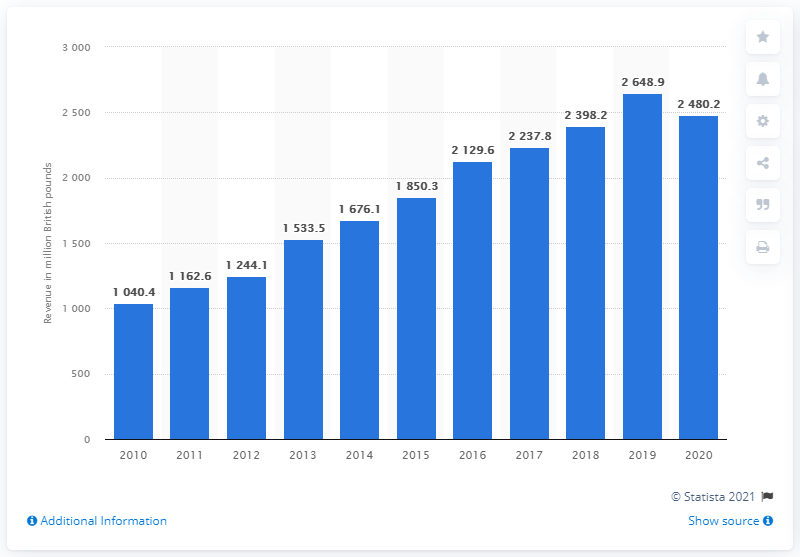Indicate a few pertinent items in this graphic. In 2020, IWG generated 2,480.2 British pounds in revenue. In 2016, Regus changed its holding company to IWG. 